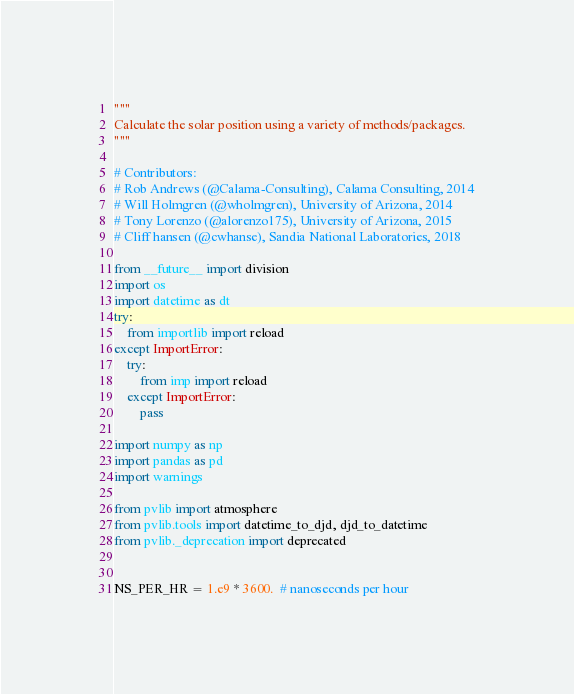Convert code to text. <code><loc_0><loc_0><loc_500><loc_500><_Python_>"""
Calculate the solar position using a variety of methods/packages.
"""

# Contributors:
# Rob Andrews (@Calama-Consulting), Calama Consulting, 2014
# Will Holmgren (@wholmgren), University of Arizona, 2014
# Tony Lorenzo (@alorenzo175), University of Arizona, 2015
# Cliff hansen (@cwhanse), Sandia National Laboratories, 2018

from __future__ import division
import os
import datetime as dt
try:
    from importlib import reload
except ImportError:
    try:
        from imp import reload
    except ImportError:
        pass

import numpy as np
import pandas as pd
import warnings

from pvlib import atmosphere
from pvlib.tools import datetime_to_djd, djd_to_datetime
from pvlib._deprecation import deprecated


NS_PER_HR = 1.e9 * 3600.  # nanoseconds per hour

</code> 